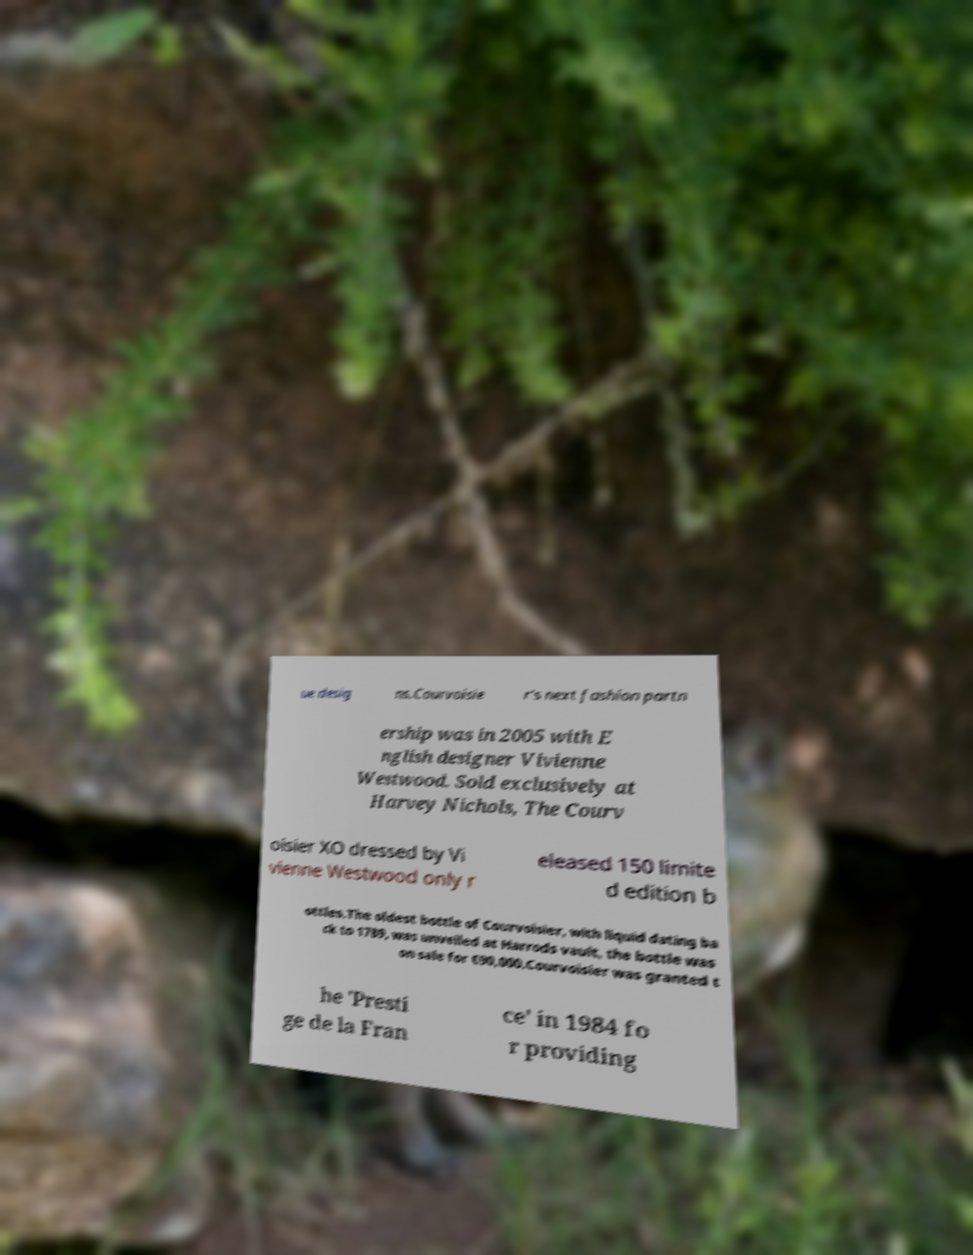Please identify and transcribe the text found in this image. ue desig ns.Courvoisie r's next fashion partn ership was in 2005 with E nglish designer Vivienne Westwood. Sold exclusively at Harvey Nichols, The Courv oisier XO dressed by Vi vienne Westwood only r eleased 150 limite d edition b ottles.The oldest bottle of Courvoisier, with liquid dating ba ck to 1789, was unveiled at Harrods vault, the bottle was on sale for €90,000.Courvoisier was granted t he 'Presti ge de la Fran ce' in 1984 fo r providing 